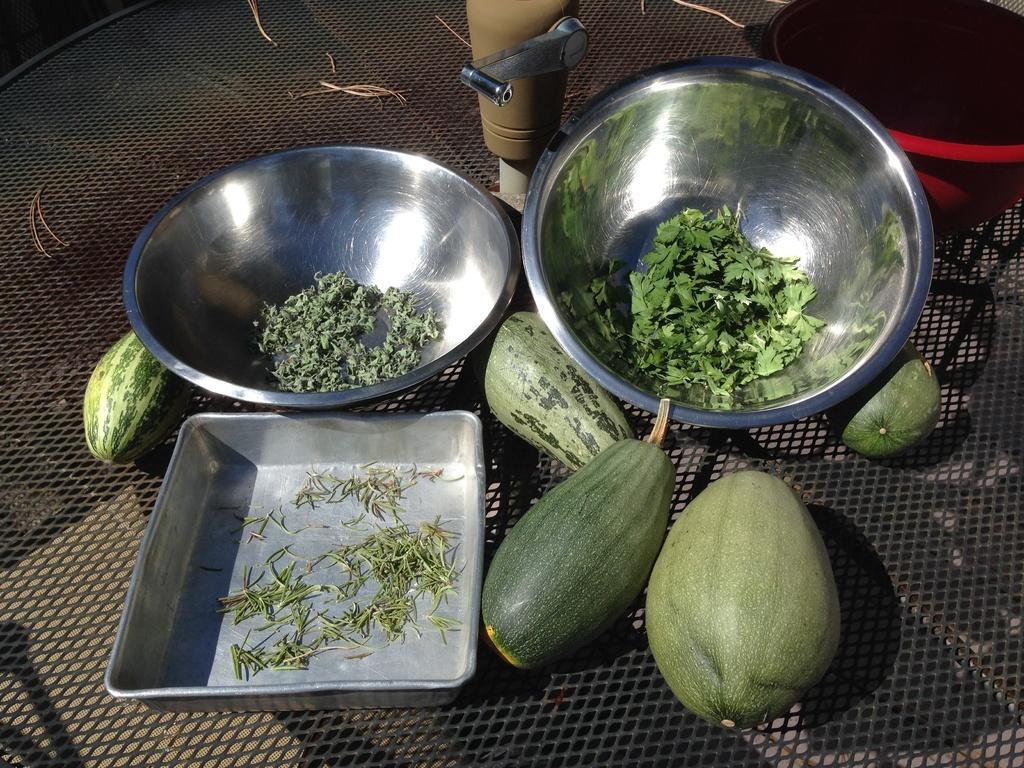Can you describe this image briefly? In this image I can see the black colored grilled surface and on it I can see a metal tray, few bowls and in the bowls I can see few herbs. I can see few fruits , a red and black colored bowl and a brown colored object on the grill. 